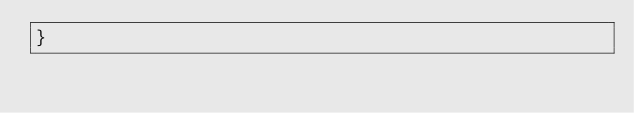<code> <loc_0><loc_0><loc_500><loc_500><_Rust_>}
</code> 